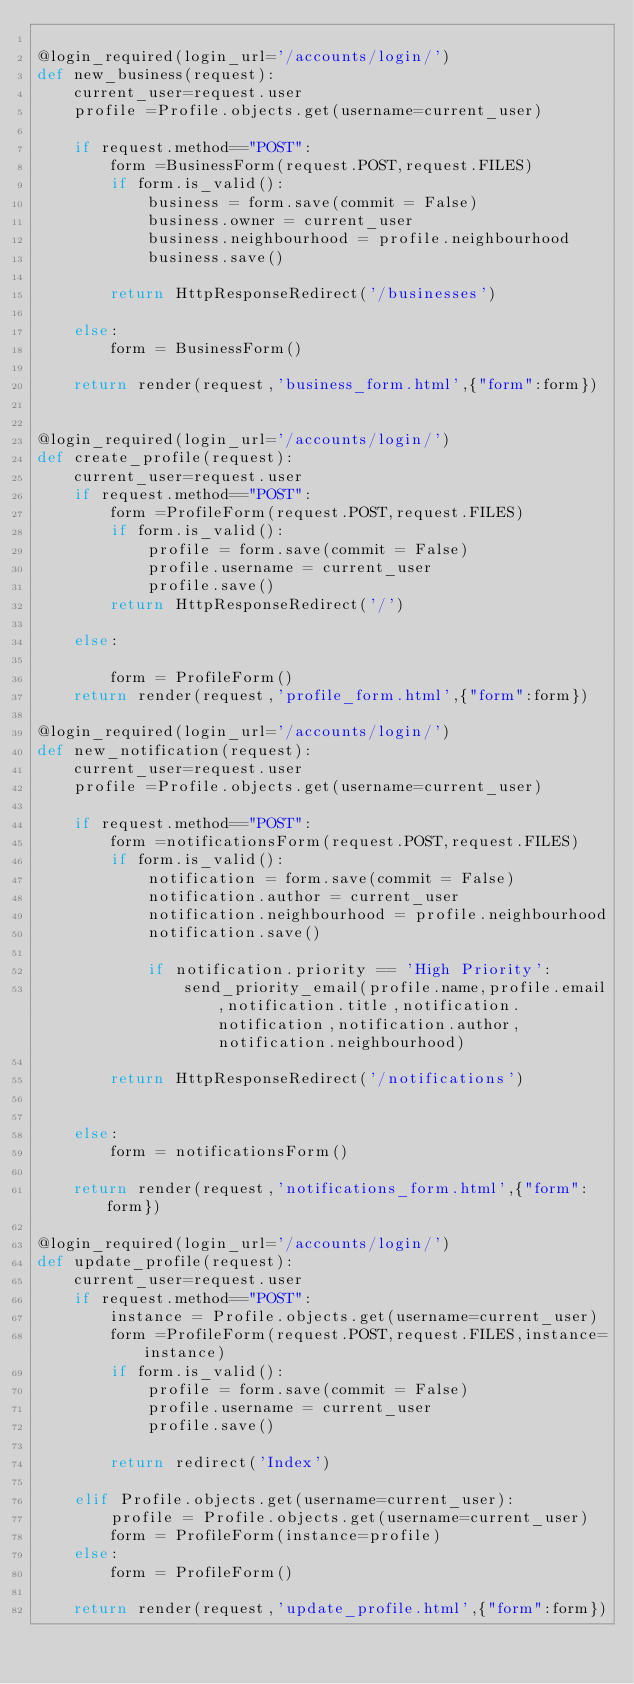<code> <loc_0><loc_0><loc_500><loc_500><_Python_>
@login_required(login_url='/accounts/login/')
def new_business(request):
    current_user=request.user
    profile =Profile.objects.get(username=current_user)

    if request.method=="POST":
        form =BusinessForm(request.POST,request.FILES)
        if form.is_valid():
            business = form.save(commit = False)
            business.owner = current_user
            business.neighbourhood = profile.neighbourhood
            business.save()

        return HttpResponseRedirect('/businesses')

    else:
        form = BusinessForm()

    return render(request,'business_form.html',{"form":form})


@login_required(login_url='/accounts/login/')
def create_profile(request):
    current_user=request.user
    if request.method=="POST":
        form =ProfileForm(request.POST,request.FILES)
        if form.is_valid():
            profile = form.save(commit = False)
            profile.username = current_user
            profile.save()
        return HttpResponseRedirect('/')

    else:

        form = ProfileForm()
    return render(request,'profile_form.html',{"form":form})

@login_required(login_url='/accounts/login/')
def new_notification(request):
    current_user=request.user
    profile =Profile.objects.get(username=current_user)

    if request.method=="POST":
        form =notificationsForm(request.POST,request.FILES)
        if form.is_valid():
            notification = form.save(commit = False)
            notification.author = current_user
            notification.neighbourhood = profile.neighbourhood
            notification.save()

            if notification.priority == 'High Priority':
                send_priority_email(profile.name,profile.email,notification.title,notification.notification,notification.author,notification.neighbourhood)

        return HttpResponseRedirect('/notifications')


    else:
        form = notificationsForm()

    return render(request,'notifications_form.html',{"form":form})

@login_required(login_url='/accounts/login/')
def update_profile(request):
    current_user=request.user
    if request.method=="POST":
        instance = Profile.objects.get(username=current_user)
        form =ProfileForm(request.POST,request.FILES,instance=instance)
        if form.is_valid():
            profile = form.save(commit = False)
            profile.username = current_user
            profile.save()

        return redirect('Index')

    elif Profile.objects.get(username=current_user):
        profile = Profile.objects.get(username=current_user)
        form = ProfileForm(instance=profile)
    else:
        form = ProfileForm()

    return render(request,'update_profile.html',{"form":form})
</code> 